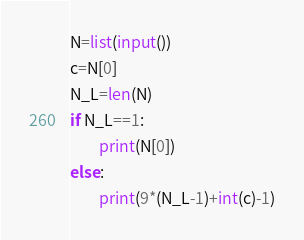<code> <loc_0><loc_0><loc_500><loc_500><_Python_>N=list(input())
c=N[0]
N_L=len(N)
if N_L==1:
        print(N[0])
else:
        print(9*(N_L-1)+int(c)-1)</code> 